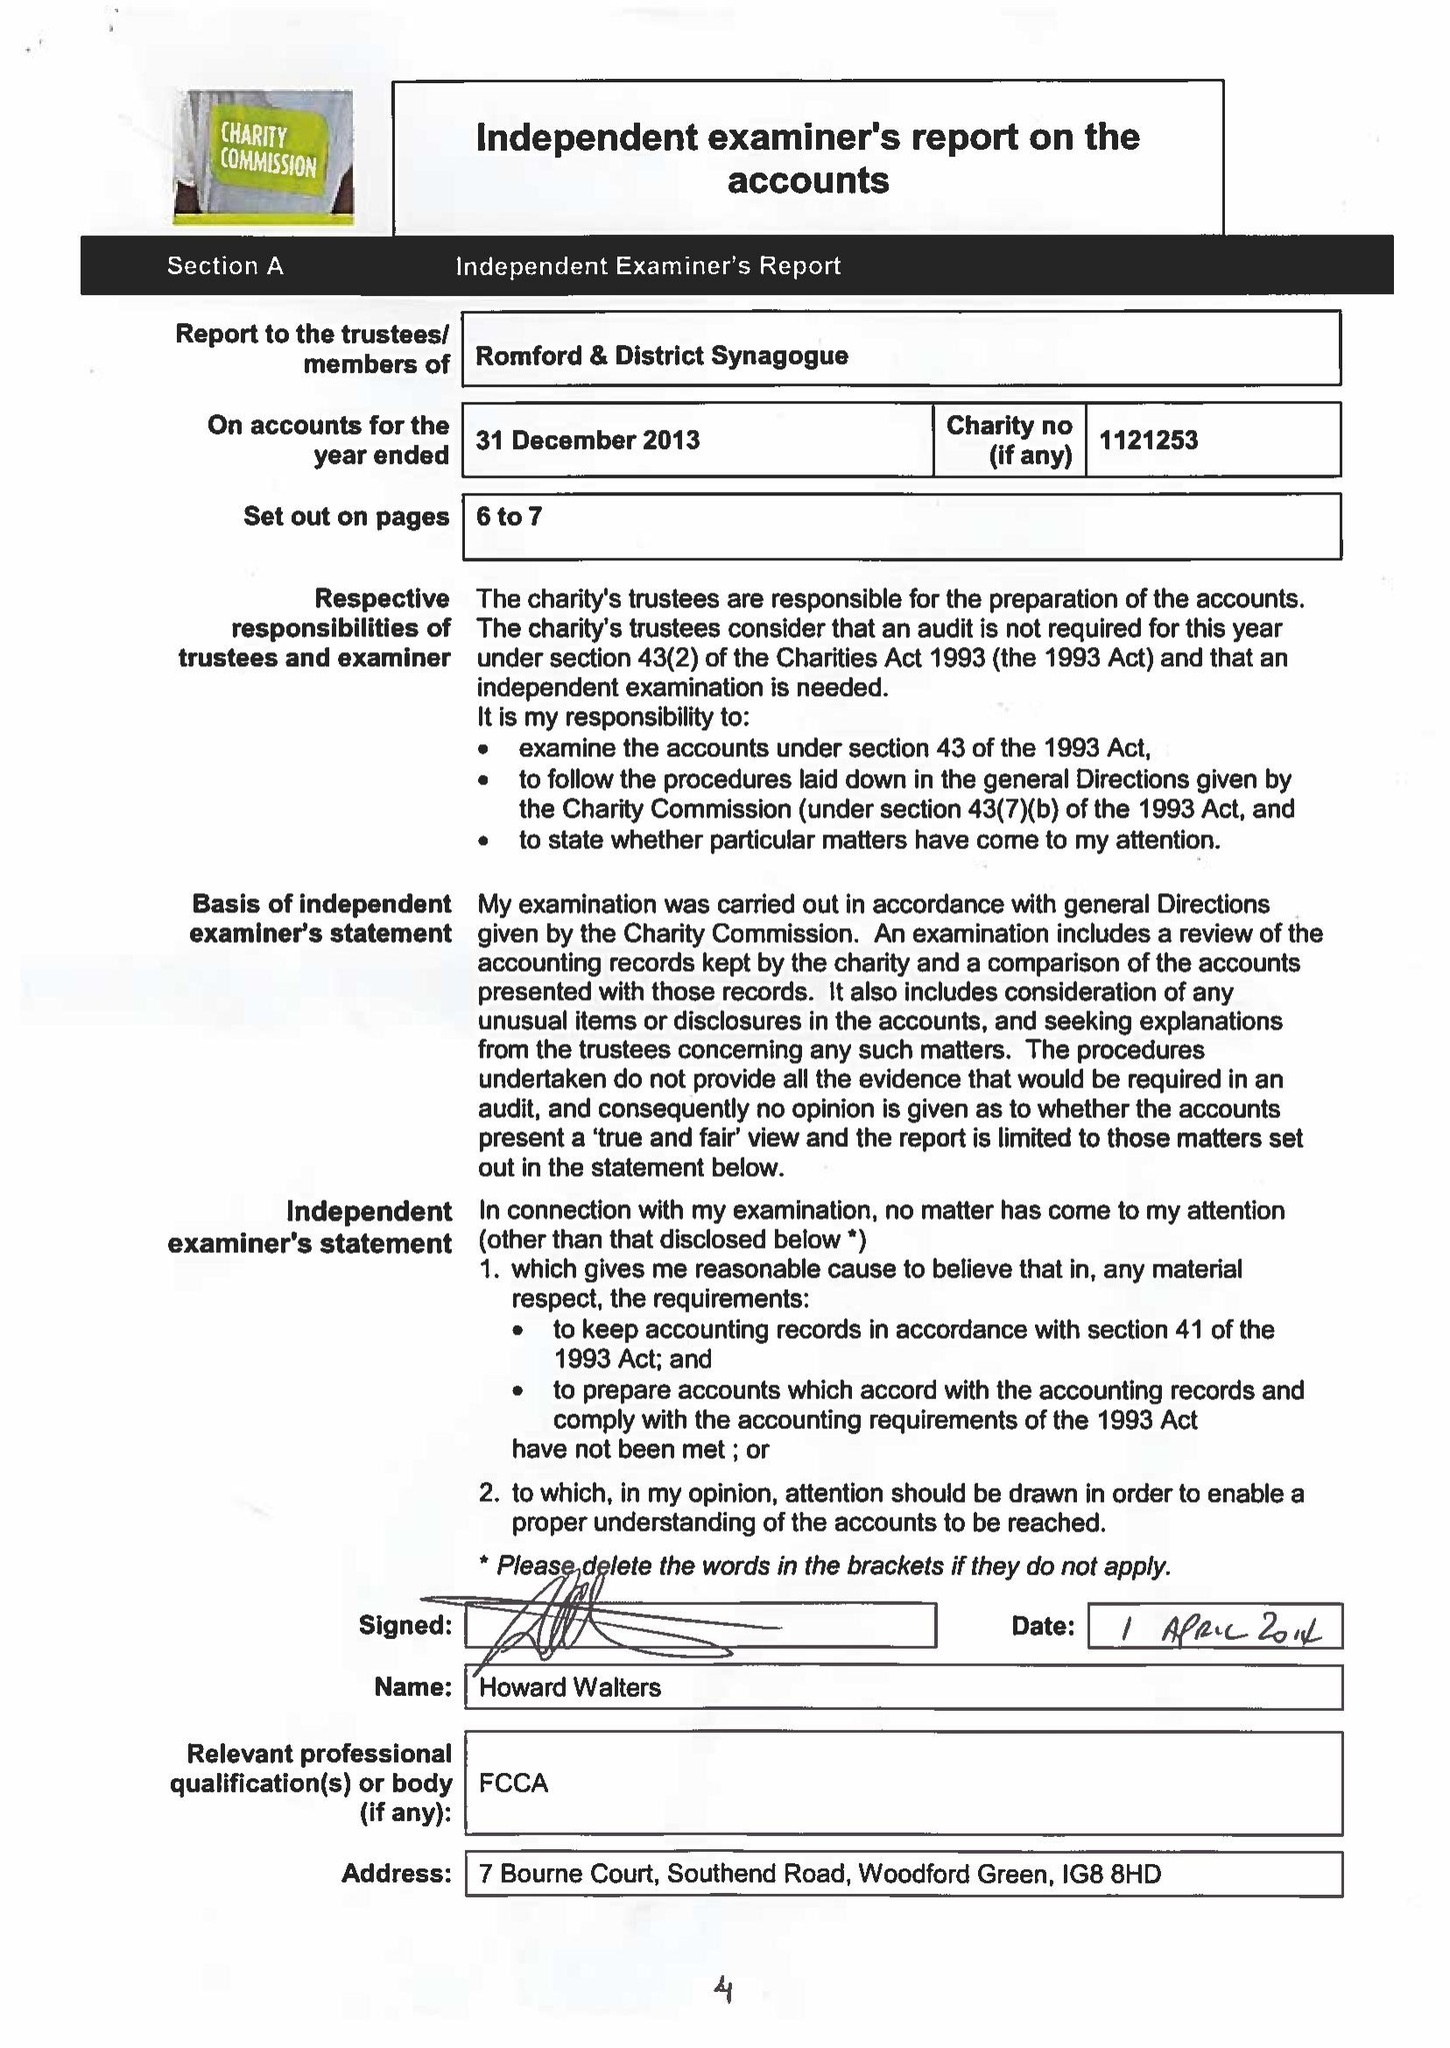What is the value for the income_annually_in_british_pounds?
Answer the question using a single word or phrase. 60930.00 